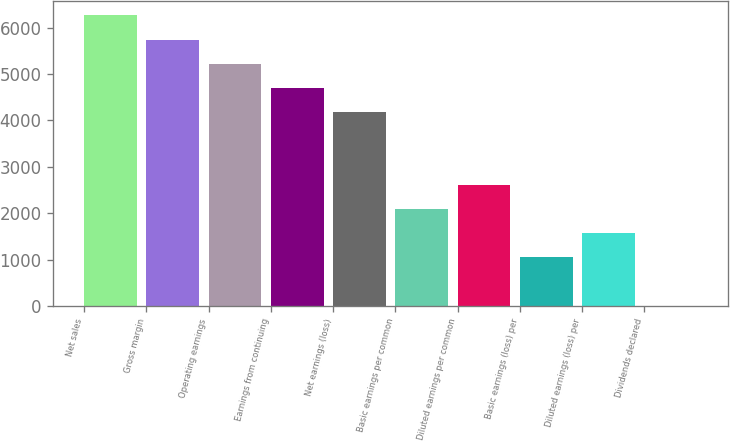<chart> <loc_0><loc_0><loc_500><loc_500><bar_chart><fcel>Net sales<fcel>Gross margin<fcel>Operating earnings<fcel>Earnings from continuing<fcel>Net earnings (loss)<fcel>Basic earnings per common<fcel>Diluted earnings per common<fcel>Basic earnings (loss) per<fcel>Diluted earnings (loss) per<fcel>Dividends declared<nl><fcel>6262.84<fcel>5740.94<fcel>5219.04<fcel>4697.14<fcel>4175.24<fcel>2087.64<fcel>2609.54<fcel>1043.84<fcel>1565.74<fcel>0.04<nl></chart> 